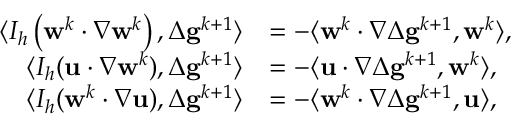Convert formula to latex. <formula><loc_0><loc_0><loc_500><loc_500>\begin{array} { r l } { \langle I _ { h } \left ( w ^ { k } \cdot \nabla w ^ { k } \right ) , \Delta g ^ { k + 1 } \rangle } & { = - \langle w ^ { k } \cdot \nabla \Delta g ^ { k + 1 } , w ^ { k } \rangle , } \\ { \langle I _ { h } ( u \cdot \nabla w ^ { k } ) , \Delta g ^ { k + 1 } \rangle } & { = - \langle u \cdot \nabla \Delta g ^ { k + 1 } , w ^ { k } \rangle , } \\ { \langle I _ { h } ( w ^ { k } \cdot \nabla u ) , \Delta g ^ { k + 1 } \rangle } & { = - \langle w ^ { k } \cdot \nabla \Delta g ^ { k + 1 } , u \rangle , } \end{array}</formula> 